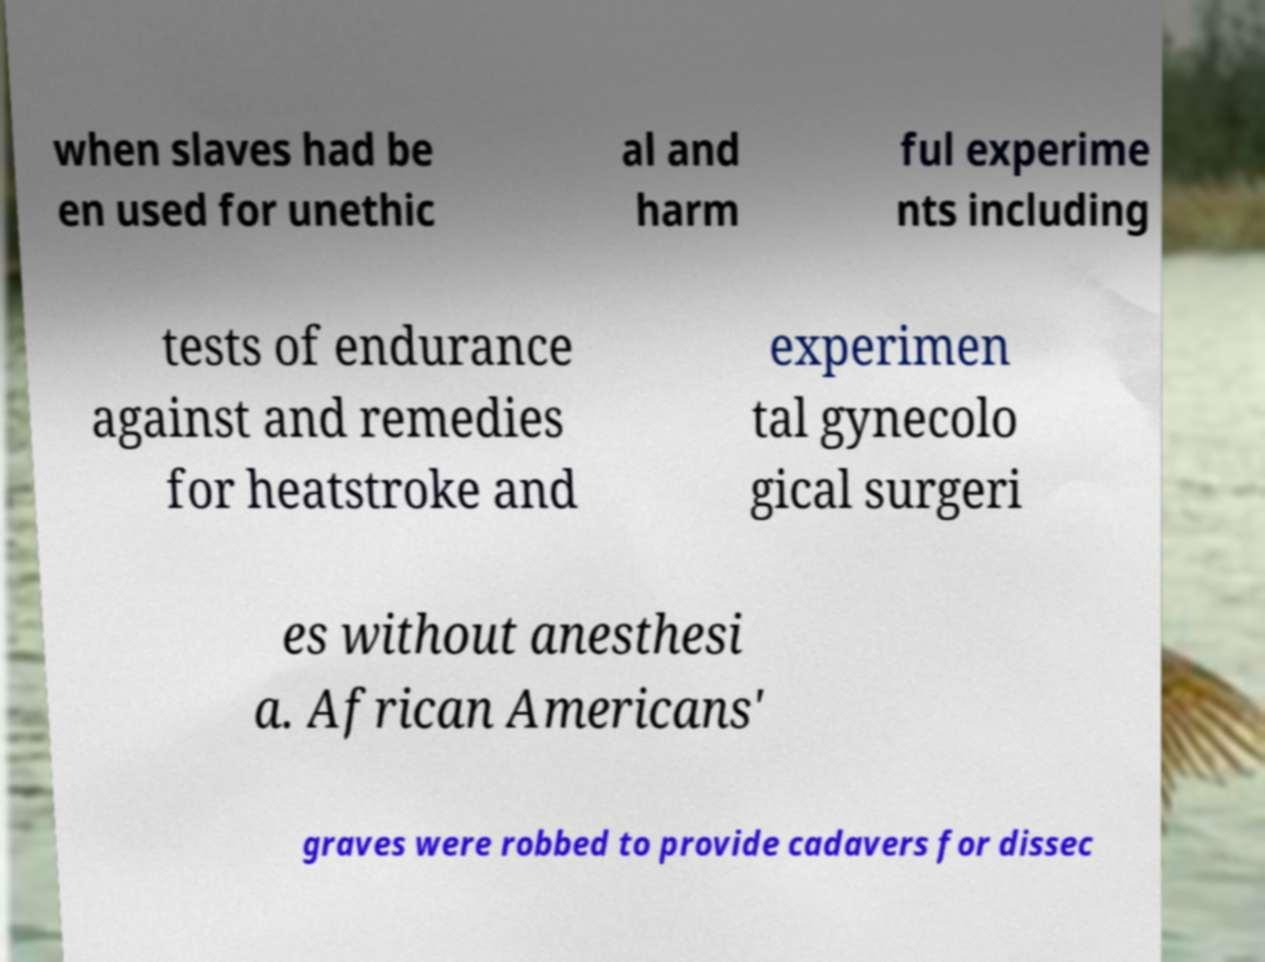Can you read and provide the text displayed in the image?This photo seems to have some interesting text. Can you extract and type it out for me? when slaves had be en used for unethic al and harm ful experime nts including tests of endurance against and remedies for heatstroke and experimen tal gynecolo gical surgeri es without anesthesi a. African Americans' graves were robbed to provide cadavers for dissec 